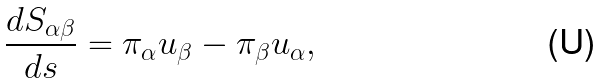Convert formula to latex. <formula><loc_0><loc_0><loc_500><loc_500>\frac { d S _ { \alpha \beta } } { d s } = \pi _ { \alpha } u _ { \beta } - \pi _ { \beta } u _ { \alpha } ,</formula> 